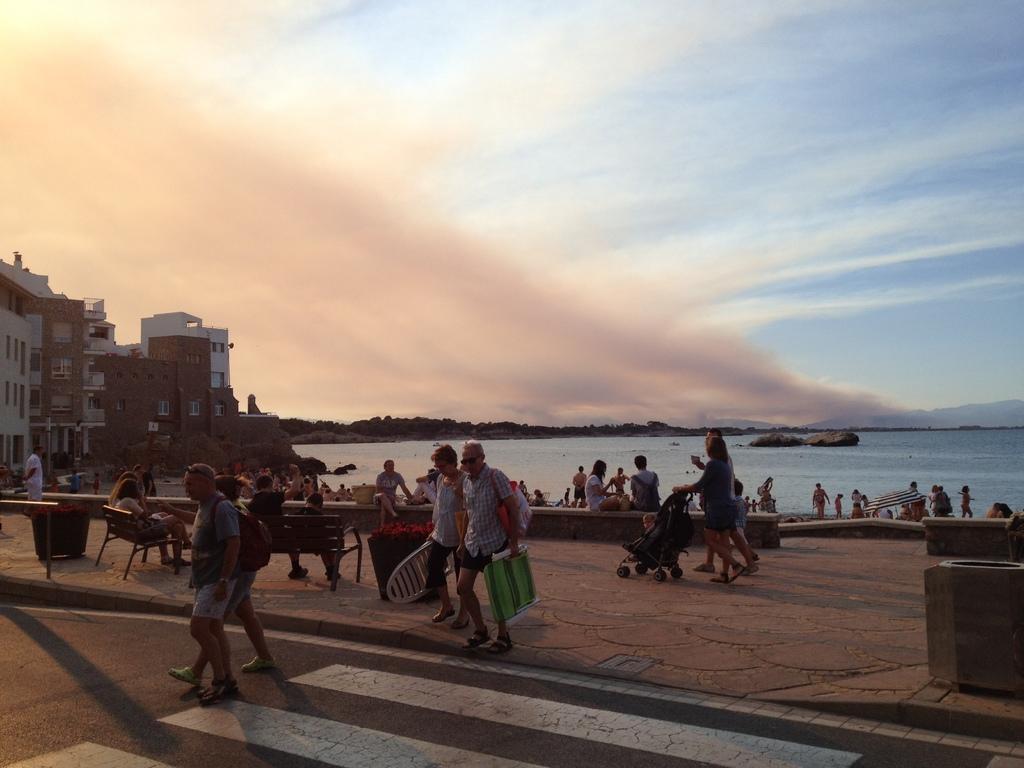Can you describe this image briefly? In this image, we can see people and some are sitting on the benches and some are holding objects and we can see a kid in the trolley. In the background, there are buildings and trees and we can see some objects and there is water. At the top, there are clouds in the sky and at the bottom, there is a road. 